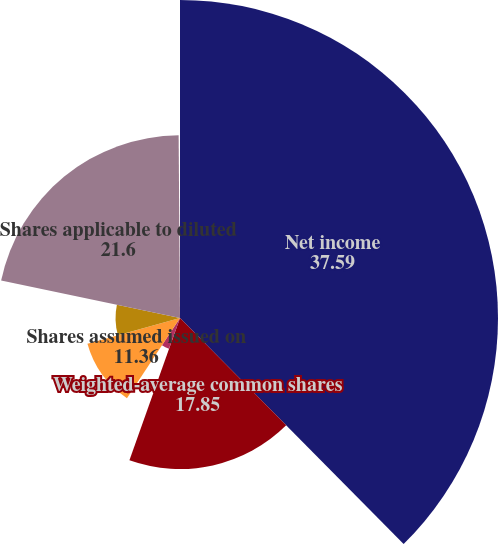Convert chart. <chart><loc_0><loc_0><loc_500><loc_500><pie_chart><fcel>Net income<fcel>Weighted-average common shares<fcel>Basic EPS<fcel>Shares assumed issued on<fcel>Shares assumed purchased with<fcel>Shares applicable to diluted<fcel>Diluted EPS<nl><fcel>37.59%<fcel>17.85%<fcel>3.87%<fcel>11.36%<fcel>7.62%<fcel>21.6%<fcel>0.12%<nl></chart> 